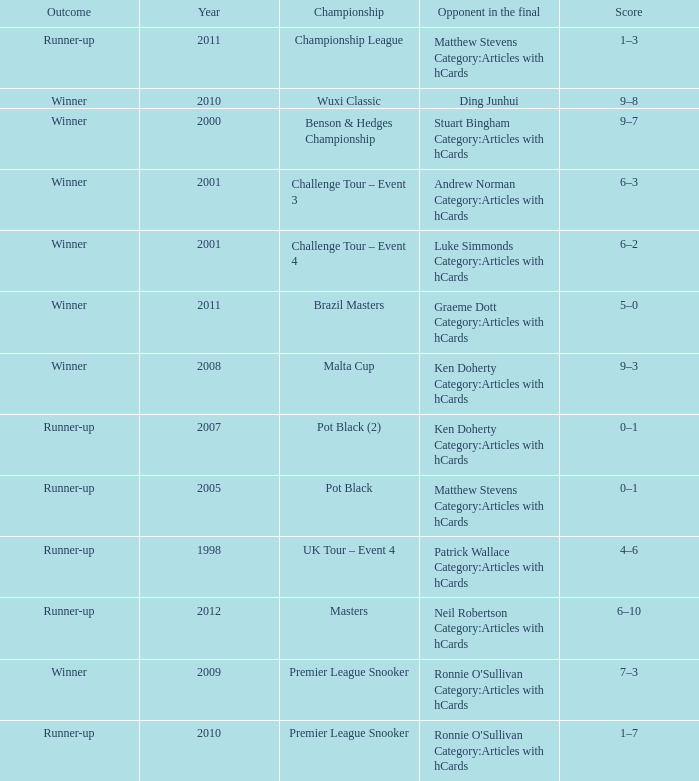What was Shaun Murphy's outcome in the Premier League Snooker championship held before 2010? Winner. 